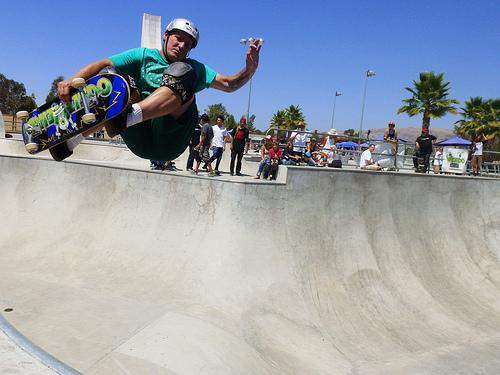Describe the image while focusing on the skateboard and the trick being performed. The man is performing a daring skateboard trick, leaping into the air on his blue skateboard with green lettering, wearing a silver helmet for safety. Describe the image focusing on the attire of the main person. The skateboarder is dressed in a green shirt, red hat, silver helmet, and black kneepads while executing a trick in front of an audience. Write a concise description of the image, mentioning the scenery and main character. Amid a scenic backdrop of blue sky, hills, and palm trees, a skateboarder in a green shirt and silver helmet executes a mid-air trick. Mention the setting of the image and the activity of the main character. In a concrete skate park with an empty pool, light posts, and palm trees behind a fence, a man attempts a mid-air trick on his blue skateboard. Provide a description of the image mentioning the skate park's infrastructure. At a skateboard park featuring a large empty pool, curved cement ramps, and distant hills, a man performs a mid-air trick on his skateboard, wearing a silver helmet. Provide a brief description of the primary action taking place in the image. A man is performing a skateboarding trick, wearing a green shirt, red hat, and silver helmet, while spectators watch. Describe the image, focusing on the onlookers and their position in relation to the main subject. As a man performs a skateboarding trick, a group of teenagers, onlookers, and people in various attire observe him from their positions near the lamp posts and palm trees. Provide a general description of the image, including the main character, their attire, and the atmosphere of the scene. In a casual, outdoorsy setting with palm trees and light posts, a man is skateboarding while wearing a green shirt, red hat, silver helmet, and black kneepads, as spectators look on. Write a brief summary of the image, highlighting any notable objects or features of the scene. A man in mid-air, wearing a silver helmet, executes a skateboard trick at an empty poolside skate park adorned with streetlights, palm trees, and a blue umbrella. Write a sentence summarizing the overall scene depicted in the image. The image captures a skateboarding man performing a mid-air trick, surrounded by onlookers in a skate park with palm trees and hills in the background. 